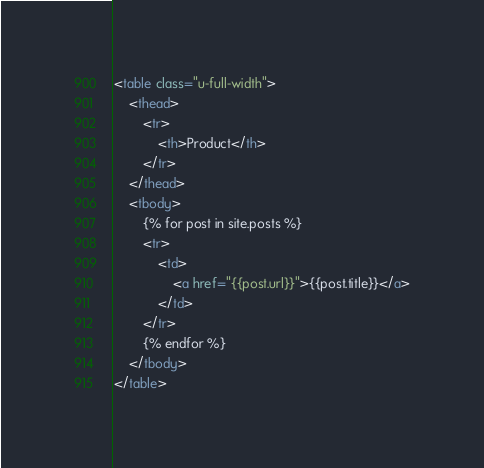<code> <loc_0><loc_0><loc_500><loc_500><_HTML_><table class="u-full-width">
    <thead>
        <tr>
            <th>Product</th>
        </tr>
    </thead>
    <tbody>
        {% for post in site.posts %}
        <tr>
            <td>
                <a href="{{post.url}}">{{post.title}}</a>
            </td>
        </tr>
        {% endfor %}
    </tbody>
</table>
</code> 